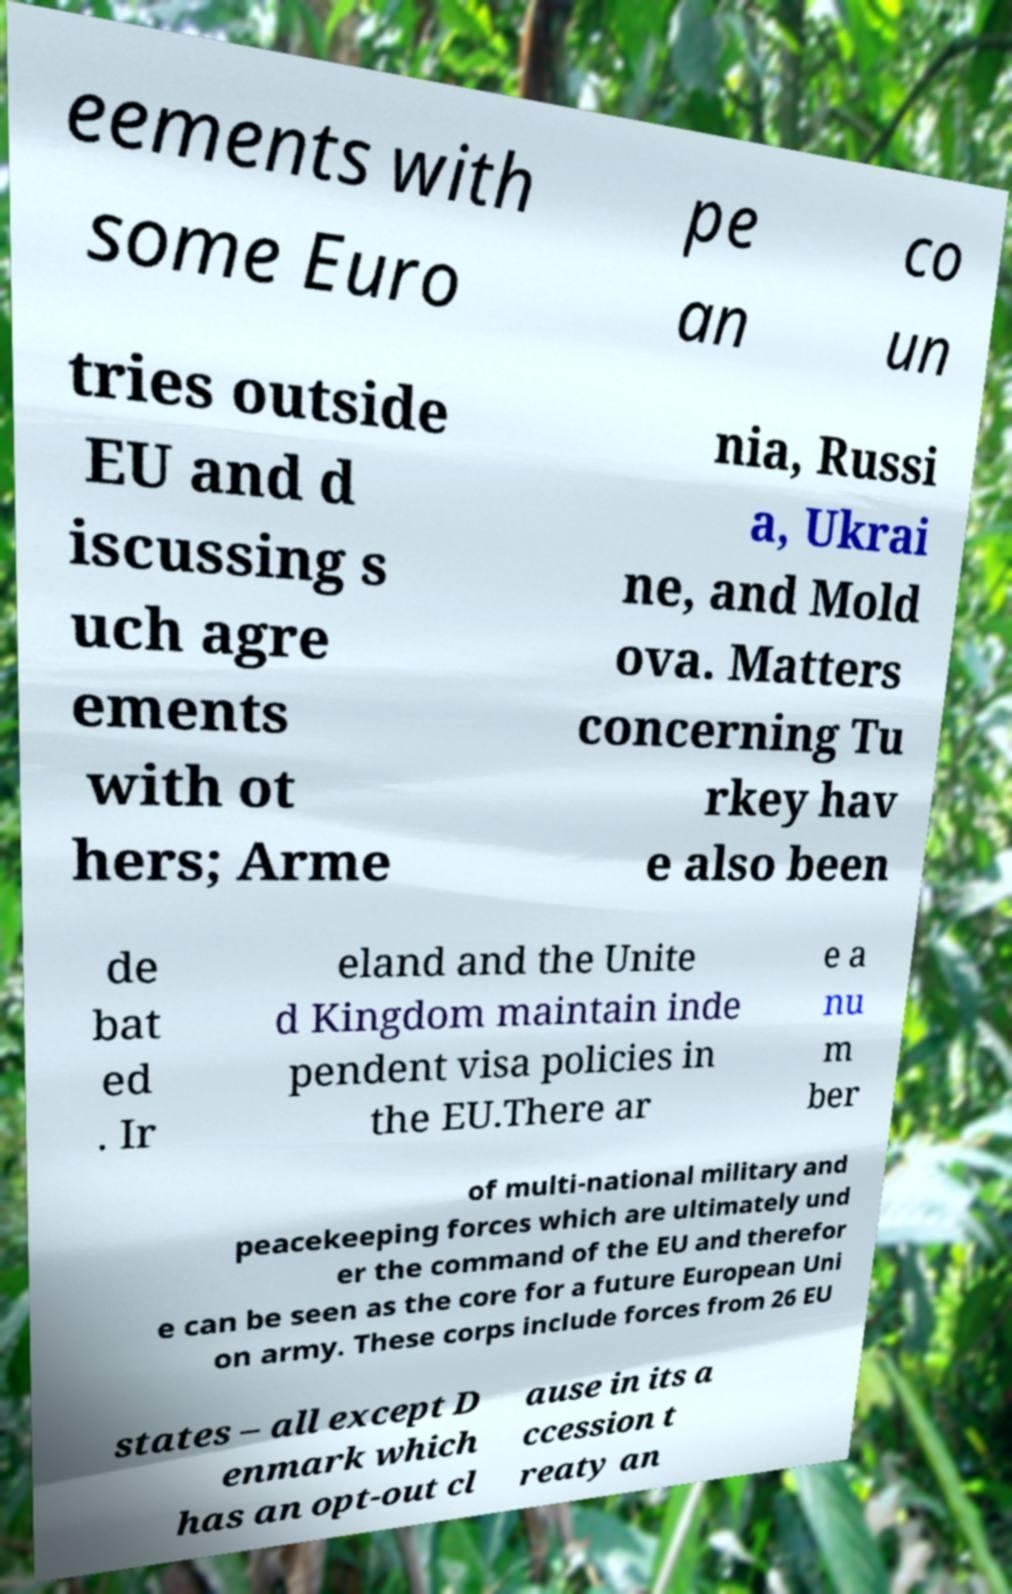Please identify and transcribe the text found in this image. eements with some Euro pe an co un tries outside EU and d iscussing s uch agre ements with ot hers; Arme nia, Russi a, Ukrai ne, and Mold ova. Matters concerning Tu rkey hav e also been de bat ed . Ir eland and the Unite d Kingdom maintain inde pendent visa policies in the EU.There ar e a nu m ber of multi-national military and peacekeeping forces which are ultimately und er the command of the EU and therefor e can be seen as the core for a future European Uni on army. These corps include forces from 26 EU states – all except D enmark which has an opt-out cl ause in its a ccession t reaty an 